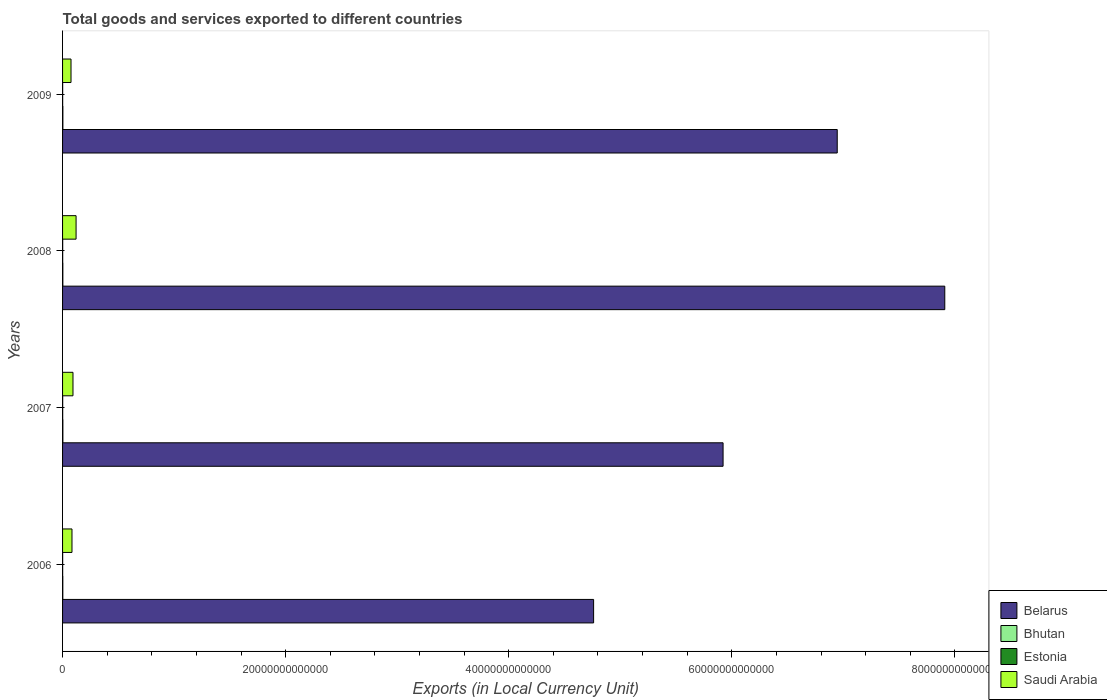How many different coloured bars are there?
Provide a short and direct response. 4. How many groups of bars are there?
Give a very brief answer. 4. How many bars are there on the 2nd tick from the top?
Provide a short and direct response. 4. How many bars are there on the 2nd tick from the bottom?
Give a very brief answer. 4. What is the label of the 3rd group of bars from the top?
Your answer should be very brief. 2007. In how many cases, is the number of bars for a given year not equal to the number of legend labels?
Your response must be concise. 0. What is the Amount of goods and services exports in Bhutan in 2007?
Offer a very short reply. 2.72e+1. Across all years, what is the maximum Amount of goods and services exports in Estonia?
Your answer should be very brief. 1.10e+1. Across all years, what is the minimum Amount of goods and services exports in Saudi Arabia?
Offer a terse response. 7.58e+11. In which year was the Amount of goods and services exports in Belarus minimum?
Offer a very short reply. 2006. What is the total Amount of goods and services exports in Bhutan in the graph?
Provide a short and direct response. 1.02e+11. What is the difference between the Amount of goods and services exports in Belarus in 2008 and that in 2009?
Provide a succinct answer. 9.64e+12. What is the difference between the Amount of goods and services exports in Belarus in 2006 and the Amount of goods and services exports in Estonia in 2009?
Ensure brevity in your answer.  4.76e+13. What is the average Amount of goods and services exports in Estonia per year?
Keep it short and to the point. 9.62e+09. In the year 2007, what is the difference between the Amount of goods and services exports in Belarus and Amount of goods and services exports in Estonia?
Your answer should be compact. 5.92e+13. In how many years, is the Amount of goods and services exports in Saudi Arabia greater than 48000000000000 LCU?
Your answer should be compact. 0. What is the ratio of the Amount of goods and services exports in Bhutan in 2008 to that in 2009?
Provide a short and direct response. 0.93. Is the difference between the Amount of goods and services exports in Belarus in 2008 and 2009 greater than the difference between the Amount of goods and services exports in Estonia in 2008 and 2009?
Keep it short and to the point. Yes. What is the difference between the highest and the second highest Amount of goods and services exports in Saudi Arabia?
Your answer should be very brief. 2.76e+11. What is the difference between the highest and the lowest Amount of goods and services exports in Estonia?
Offer a very short reply. 2.45e+09. What does the 1st bar from the top in 2009 represents?
Provide a succinct answer. Saudi Arabia. What does the 4th bar from the bottom in 2007 represents?
Your response must be concise. Saudi Arabia. Are all the bars in the graph horizontal?
Your answer should be compact. Yes. How many years are there in the graph?
Provide a succinct answer. 4. What is the difference between two consecutive major ticks on the X-axis?
Make the answer very short. 2.00e+13. Does the graph contain any zero values?
Provide a succinct answer. No. Does the graph contain grids?
Offer a terse response. No. How many legend labels are there?
Offer a terse response. 4. How are the legend labels stacked?
Provide a succinct answer. Vertical. What is the title of the graph?
Offer a terse response. Total goods and services exported to different countries. Does "El Salvador" appear as one of the legend labels in the graph?
Your answer should be compact. No. What is the label or title of the X-axis?
Provide a succinct answer. Exports (in Local Currency Unit). What is the Exports (in Local Currency Unit) of Belarus in 2006?
Ensure brevity in your answer.  4.76e+13. What is the Exports (in Local Currency Unit) of Bhutan in 2006?
Make the answer very short. 2.21e+1. What is the Exports (in Local Currency Unit) in Estonia in 2006?
Your answer should be compact. 8.58e+09. What is the Exports (in Local Currency Unit) in Saudi Arabia in 2006?
Ensure brevity in your answer.  8.45e+11. What is the Exports (in Local Currency Unit) in Belarus in 2007?
Make the answer very short. 5.92e+13. What is the Exports (in Local Currency Unit) in Bhutan in 2007?
Provide a short and direct response. 2.72e+1. What is the Exports (in Local Currency Unit) in Estonia in 2007?
Make the answer very short. 1.03e+1. What is the Exports (in Local Currency Unit) of Saudi Arabia in 2007?
Your answer should be compact. 9.34e+11. What is the Exports (in Local Currency Unit) of Belarus in 2008?
Offer a terse response. 7.91e+13. What is the Exports (in Local Currency Unit) of Bhutan in 2008?
Provide a short and direct response. 2.55e+1. What is the Exports (in Local Currency Unit) in Estonia in 2008?
Give a very brief answer. 1.10e+1. What is the Exports (in Local Currency Unit) of Saudi Arabia in 2008?
Your answer should be compact. 1.21e+12. What is the Exports (in Local Currency Unit) in Belarus in 2009?
Give a very brief answer. 6.94e+13. What is the Exports (in Local Currency Unit) in Bhutan in 2009?
Ensure brevity in your answer.  2.74e+1. What is the Exports (in Local Currency Unit) in Estonia in 2009?
Offer a very short reply. 8.60e+09. What is the Exports (in Local Currency Unit) in Saudi Arabia in 2009?
Your answer should be very brief. 7.58e+11. Across all years, what is the maximum Exports (in Local Currency Unit) of Belarus?
Offer a terse response. 7.91e+13. Across all years, what is the maximum Exports (in Local Currency Unit) of Bhutan?
Offer a terse response. 2.74e+1. Across all years, what is the maximum Exports (in Local Currency Unit) in Estonia?
Give a very brief answer. 1.10e+1. Across all years, what is the maximum Exports (in Local Currency Unit) of Saudi Arabia?
Ensure brevity in your answer.  1.21e+12. Across all years, what is the minimum Exports (in Local Currency Unit) in Belarus?
Give a very brief answer. 4.76e+13. Across all years, what is the minimum Exports (in Local Currency Unit) of Bhutan?
Give a very brief answer. 2.21e+1. Across all years, what is the minimum Exports (in Local Currency Unit) of Estonia?
Give a very brief answer. 8.58e+09. Across all years, what is the minimum Exports (in Local Currency Unit) in Saudi Arabia?
Provide a succinct answer. 7.58e+11. What is the total Exports (in Local Currency Unit) of Belarus in the graph?
Provide a succinct answer. 2.55e+14. What is the total Exports (in Local Currency Unit) in Bhutan in the graph?
Your response must be concise. 1.02e+11. What is the total Exports (in Local Currency Unit) of Estonia in the graph?
Provide a succinct answer. 3.85e+1. What is the total Exports (in Local Currency Unit) in Saudi Arabia in the graph?
Provide a short and direct response. 3.75e+12. What is the difference between the Exports (in Local Currency Unit) in Belarus in 2006 and that in 2007?
Make the answer very short. -1.16e+13. What is the difference between the Exports (in Local Currency Unit) of Bhutan in 2006 and that in 2007?
Provide a succinct answer. -5.05e+09. What is the difference between the Exports (in Local Currency Unit) in Estonia in 2006 and that in 2007?
Give a very brief answer. -1.68e+09. What is the difference between the Exports (in Local Currency Unit) in Saudi Arabia in 2006 and that in 2007?
Offer a very short reply. -8.98e+1. What is the difference between the Exports (in Local Currency Unit) of Belarus in 2006 and that in 2008?
Your answer should be very brief. -3.15e+13. What is the difference between the Exports (in Local Currency Unit) of Bhutan in 2006 and that in 2008?
Ensure brevity in your answer.  -3.35e+09. What is the difference between the Exports (in Local Currency Unit) of Estonia in 2006 and that in 2008?
Ensure brevity in your answer.  -2.45e+09. What is the difference between the Exports (in Local Currency Unit) in Saudi Arabia in 2006 and that in 2008?
Your answer should be very brief. -3.66e+11. What is the difference between the Exports (in Local Currency Unit) of Belarus in 2006 and that in 2009?
Your response must be concise. -2.18e+13. What is the difference between the Exports (in Local Currency Unit) in Bhutan in 2006 and that in 2009?
Ensure brevity in your answer.  -5.23e+09. What is the difference between the Exports (in Local Currency Unit) in Estonia in 2006 and that in 2009?
Your response must be concise. -1.66e+07. What is the difference between the Exports (in Local Currency Unit) of Saudi Arabia in 2006 and that in 2009?
Ensure brevity in your answer.  8.68e+1. What is the difference between the Exports (in Local Currency Unit) of Belarus in 2007 and that in 2008?
Offer a very short reply. -1.99e+13. What is the difference between the Exports (in Local Currency Unit) of Bhutan in 2007 and that in 2008?
Your response must be concise. 1.70e+09. What is the difference between the Exports (in Local Currency Unit) of Estonia in 2007 and that in 2008?
Keep it short and to the point. -7.66e+08. What is the difference between the Exports (in Local Currency Unit) in Saudi Arabia in 2007 and that in 2008?
Your answer should be very brief. -2.76e+11. What is the difference between the Exports (in Local Currency Unit) of Belarus in 2007 and that in 2009?
Keep it short and to the point. -1.02e+13. What is the difference between the Exports (in Local Currency Unit) of Bhutan in 2007 and that in 2009?
Provide a short and direct response. -1.80e+08. What is the difference between the Exports (in Local Currency Unit) of Estonia in 2007 and that in 2009?
Your answer should be very brief. 1.67e+09. What is the difference between the Exports (in Local Currency Unit) of Saudi Arabia in 2007 and that in 2009?
Provide a succinct answer. 1.77e+11. What is the difference between the Exports (in Local Currency Unit) in Belarus in 2008 and that in 2009?
Make the answer very short. 9.64e+12. What is the difference between the Exports (in Local Currency Unit) of Bhutan in 2008 and that in 2009?
Provide a short and direct response. -1.88e+09. What is the difference between the Exports (in Local Currency Unit) of Estonia in 2008 and that in 2009?
Your answer should be compact. 2.43e+09. What is the difference between the Exports (in Local Currency Unit) in Saudi Arabia in 2008 and that in 2009?
Offer a very short reply. 4.53e+11. What is the difference between the Exports (in Local Currency Unit) of Belarus in 2006 and the Exports (in Local Currency Unit) of Bhutan in 2007?
Provide a short and direct response. 4.76e+13. What is the difference between the Exports (in Local Currency Unit) in Belarus in 2006 and the Exports (in Local Currency Unit) in Estonia in 2007?
Offer a very short reply. 4.76e+13. What is the difference between the Exports (in Local Currency Unit) in Belarus in 2006 and the Exports (in Local Currency Unit) in Saudi Arabia in 2007?
Your response must be concise. 4.67e+13. What is the difference between the Exports (in Local Currency Unit) of Bhutan in 2006 and the Exports (in Local Currency Unit) of Estonia in 2007?
Offer a terse response. 1.19e+1. What is the difference between the Exports (in Local Currency Unit) in Bhutan in 2006 and the Exports (in Local Currency Unit) in Saudi Arabia in 2007?
Your answer should be compact. -9.12e+11. What is the difference between the Exports (in Local Currency Unit) of Estonia in 2006 and the Exports (in Local Currency Unit) of Saudi Arabia in 2007?
Make the answer very short. -9.26e+11. What is the difference between the Exports (in Local Currency Unit) in Belarus in 2006 and the Exports (in Local Currency Unit) in Bhutan in 2008?
Your answer should be compact. 4.76e+13. What is the difference between the Exports (in Local Currency Unit) of Belarus in 2006 and the Exports (in Local Currency Unit) of Estonia in 2008?
Your response must be concise. 4.76e+13. What is the difference between the Exports (in Local Currency Unit) of Belarus in 2006 and the Exports (in Local Currency Unit) of Saudi Arabia in 2008?
Your answer should be very brief. 4.64e+13. What is the difference between the Exports (in Local Currency Unit) in Bhutan in 2006 and the Exports (in Local Currency Unit) in Estonia in 2008?
Give a very brief answer. 1.11e+1. What is the difference between the Exports (in Local Currency Unit) of Bhutan in 2006 and the Exports (in Local Currency Unit) of Saudi Arabia in 2008?
Provide a short and direct response. -1.19e+12. What is the difference between the Exports (in Local Currency Unit) of Estonia in 2006 and the Exports (in Local Currency Unit) of Saudi Arabia in 2008?
Offer a terse response. -1.20e+12. What is the difference between the Exports (in Local Currency Unit) of Belarus in 2006 and the Exports (in Local Currency Unit) of Bhutan in 2009?
Provide a short and direct response. 4.76e+13. What is the difference between the Exports (in Local Currency Unit) of Belarus in 2006 and the Exports (in Local Currency Unit) of Estonia in 2009?
Your answer should be very brief. 4.76e+13. What is the difference between the Exports (in Local Currency Unit) of Belarus in 2006 and the Exports (in Local Currency Unit) of Saudi Arabia in 2009?
Your answer should be compact. 4.69e+13. What is the difference between the Exports (in Local Currency Unit) in Bhutan in 2006 and the Exports (in Local Currency Unit) in Estonia in 2009?
Offer a terse response. 1.35e+1. What is the difference between the Exports (in Local Currency Unit) in Bhutan in 2006 and the Exports (in Local Currency Unit) in Saudi Arabia in 2009?
Make the answer very short. -7.36e+11. What is the difference between the Exports (in Local Currency Unit) in Estonia in 2006 and the Exports (in Local Currency Unit) in Saudi Arabia in 2009?
Keep it short and to the point. -7.49e+11. What is the difference between the Exports (in Local Currency Unit) in Belarus in 2007 and the Exports (in Local Currency Unit) in Bhutan in 2008?
Make the answer very short. 5.92e+13. What is the difference between the Exports (in Local Currency Unit) of Belarus in 2007 and the Exports (in Local Currency Unit) of Estonia in 2008?
Make the answer very short. 5.92e+13. What is the difference between the Exports (in Local Currency Unit) in Belarus in 2007 and the Exports (in Local Currency Unit) in Saudi Arabia in 2008?
Your response must be concise. 5.80e+13. What is the difference between the Exports (in Local Currency Unit) in Bhutan in 2007 and the Exports (in Local Currency Unit) in Estonia in 2008?
Ensure brevity in your answer.  1.62e+1. What is the difference between the Exports (in Local Currency Unit) of Bhutan in 2007 and the Exports (in Local Currency Unit) of Saudi Arabia in 2008?
Your answer should be compact. -1.18e+12. What is the difference between the Exports (in Local Currency Unit) of Estonia in 2007 and the Exports (in Local Currency Unit) of Saudi Arabia in 2008?
Give a very brief answer. -1.20e+12. What is the difference between the Exports (in Local Currency Unit) of Belarus in 2007 and the Exports (in Local Currency Unit) of Bhutan in 2009?
Your answer should be very brief. 5.92e+13. What is the difference between the Exports (in Local Currency Unit) in Belarus in 2007 and the Exports (in Local Currency Unit) in Estonia in 2009?
Your answer should be compact. 5.92e+13. What is the difference between the Exports (in Local Currency Unit) of Belarus in 2007 and the Exports (in Local Currency Unit) of Saudi Arabia in 2009?
Make the answer very short. 5.85e+13. What is the difference between the Exports (in Local Currency Unit) in Bhutan in 2007 and the Exports (in Local Currency Unit) in Estonia in 2009?
Give a very brief answer. 1.86e+1. What is the difference between the Exports (in Local Currency Unit) of Bhutan in 2007 and the Exports (in Local Currency Unit) of Saudi Arabia in 2009?
Keep it short and to the point. -7.31e+11. What is the difference between the Exports (in Local Currency Unit) of Estonia in 2007 and the Exports (in Local Currency Unit) of Saudi Arabia in 2009?
Your answer should be compact. -7.47e+11. What is the difference between the Exports (in Local Currency Unit) in Belarus in 2008 and the Exports (in Local Currency Unit) in Bhutan in 2009?
Make the answer very short. 7.91e+13. What is the difference between the Exports (in Local Currency Unit) of Belarus in 2008 and the Exports (in Local Currency Unit) of Estonia in 2009?
Provide a succinct answer. 7.91e+13. What is the difference between the Exports (in Local Currency Unit) of Belarus in 2008 and the Exports (in Local Currency Unit) of Saudi Arabia in 2009?
Your answer should be very brief. 7.83e+13. What is the difference between the Exports (in Local Currency Unit) of Bhutan in 2008 and the Exports (in Local Currency Unit) of Estonia in 2009?
Keep it short and to the point. 1.69e+1. What is the difference between the Exports (in Local Currency Unit) in Bhutan in 2008 and the Exports (in Local Currency Unit) in Saudi Arabia in 2009?
Make the answer very short. -7.32e+11. What is the difference between the Exports (in Local Currency Unit) in Estonia in 2008 and the Exports (in Local Currency Unit) in Saudi Arabia in 2009?
Provide a short and direct response. -7.47e+11. What is the average Exports (in Local Currency Unit) of Belarus per year?
Provide a succinct answer. 6.38e+13. What is the average Exports (in Local Currency Unit) of Bhutan per year?
Your response must be concise. 2.55e+1. What is the average Exports (in Local Currency Unit) in Estonia per year?
Offer a very short reply. 9.62e+09. What is the average Exports (in Local Currency Unit) of Saudi Arabia per year?
Make the answer very short. 9.37e+11. In the year 2006, what is the difference between the Exports (in Local Currency Unit) in Belarus and Exports (in Local Currency Unit) in Bhutan?
Your response must be concise. 4.76e+13. In the year 2006, what is the difference between the Exports (in Local Currency Unit) in Belarus and Exports (in Local Currency Unit) in Estonia?
Provide a short and direct response. 4.76e+13. In the year 2006, what is the difference between the Exports (in Local Currency Unit) in Belarus and Exports (in Local Currency Unit) in Saudi Arabia?
Your answer should be very brief. 4.68e+13. In the year 2006, what is the difference between the Exports (in Local Currency Unit) in Bhutan and Exports (in Local Currency Unit) in Estonia?
Provide a succinct answer. 1.35e+1. In the year 2006, what is the difference between the Exports (in Local Currency Unit) in Bhutan and Exports (in Local Currency Unit) in Saudi Arabia?
Provide a short and direct response. -8.22e+11. In the year 2006, what is the difference between the Exports (in Local Currency Unit) in Estonia and Exports (in Local Currency Unit) in Saudi Arabia?
Provide a succinct answer. -8.36e+11. In the year 2007, what is the difference between the Exports (in Local Currency Unit) of Belarus and Exports (in Local Currency Unit) of Bhutan?
Keep it short and to the point. 5.92e+13. In the year 2007, what is the difference between the Exports (in Local Currency Unit) in Belarus and Exports (in Local Currency Unit) in Estonia?
Make the answer very short. 5.92e+13. In the year 2007, what is the difference between the Exports (in Local Currency Unit) of Belarus and Exports (in Local Currency Unit) of Saudi Arabia?
Provide a short and direct response. 5.83e+13. In the year 2007, what is the difference between the Exports (in Local Currency Unit) of Bhutan and Exports (in Local Currency Unit) of Estonia?
Keep it short and to the point. 1.69e+1. In the year 2007, what is the difference between the Exports (in Local Currency Unit) of Bhutan and Exports (in Local Currency Unit) of Saudi Arabia?
Offer a terse response. -9.07e+11. In the year 2007, what is the difference between the Exports (in Local Currency Unit) of Estonia and Exports (in Local Currency Unit) of Saudi Arabia?
Provide a short and direct response. -9.24e+11. In the year 2008, what is the difference between the Exports (in Local Currency Unit) in Belarus and Exports (in Local Currency Unit) in Bhutan?
Your response must be concise. 7.91e+13. In the year 2008, what is the difference between the Exports (in Local Currency Unit) in Belarus and Exports (in Local Currency Unit) in Estonia?
Give a very brief answer. 7.91e+13. In the year 2008, what is the difference between the Exports (in Local Currency Unit) of Belarus and Exports (in Local Currency Unit) of Saudi Arabia?
Provide a short and direct response. 7.79e+13. In the year 2008, what is the difference between the Exports (in Local Currency Unit) in Bhutan and Exports (in Local Currency Unit) in Estonia?
Give a very brief answer. 1.45e+1. In the year 2008, what is the difference between the Exports (in Local Currency Unit) in Bhutan and Exports (in Local Currency Unit) in Saudi Arabia?
Your response must be concise. -1.19e+12. In the year 2008, what is the difference between the Exports (in Local Currency Unit) of Estonia and Exports (in Local Currency Unit) of Saudi Arabia?
Give a very brief answer. -1.20e+12. In the year 2009, what is the difference between the Exports (in Local Currency Unit) in Belarus and Exports (in Local Currency Unit) in Bhutan?
Keep it short and to the point. 6.94e+13. In the year 2009, what is the difference between the Exports (in Local Currency Unit) of Belarus and Exports (in Local Currency Unit) of Estonia?
Your response must be concise. 6.94e+13. In the year 2009, what is the difference between the Exports (in Local Currency Unit) of Belarus and Exports (in Local Currency Unit) of Saudi Arabia?
Offer a terse response. 6.87e+13. In the year 2009, what is the difference between the Exports (in Local Currency Unit) of Bhutan and Exports (in Local Currency Unit) of Estonia?
Offer a very short reply. 1.88e+1. In the year 2009, what is the difference between the Exports (in Local Currency Unit) in Bhutan and Exports (in Local Currency Unit) in Saudi Arabia?
Provide a succinct answer. -7.30e+11. In the year 2009, what is the difference between the Exports (in Local Currency Unit) of Estonia and Exports (in Local Currency Unit) of Saudi Arabia?
Your response must be concise. -7.49e+11. What is the ratio of the Exports (in Local Currency Unit) of Belarus in 2006 to that in 2007?
Provide a short and direct response. 0.8. What is the ratio of the Exports (in Local Currency Unit) of Bhutan in 2006 to that in 2007?
Your answer should be very brief. 0.81. What is the ratio of the Exports (in Local Currency Unit) of Estonia in 2006 to that in 2007?
Ensure brevity in your answer.  0.84. What is the ratio of the Exports (in Local Currency Unit) of Saudi Arabia in 2006 to that in 2007?
Provide a short and direct response. 0.9. What is the ratio of the Exports (in Local Currency Unit) of Belarus in 2006 to that in 2008?
Your response must be concise. 0.6. What is the ratio of the Exports (in Local Currency Unit) of Bhutan in 2006 to that in 2008?
Offer a terse response. 0.87. What is the ratio of the Exports (in Local Currency Unit) in Estonia in 2006 to that in 2008?
Provide a short and direct response. 0.78. What is the ratio of the Exports (in Local Currency Unit) in Saudi Arabia in 2006 to that in 2008?
Provide a short and direct response. 0.7. What is the ratio of the Exports (in Local Currency Unit) of Belarus in 2006 to that in 2009?
Ensure brevity in your answer.  0.69. What is the ratio of the Exports (in Local Currency Unit) of Bhutan in 2006 to that in 2009?
Offer a terse response. 0.81. What is the ratio of the Exports (in Local Currency Unit) of Saudi Arabia in 2006 to that in 2009?
Your answer should be very brief. 1.11. What is the ratio of the Exports (in Local Currency Unit) in Belarus in 2007 to that in 2008?
Offer a terse response. 0.75. What is the ratio of the Exports (in Local Currency Unit) in Bhutan in 2007 to that in 2008?
Provide a succinct answer. 1.07. What is the ratio of the Exports (in Local Currency Unit) in Estonia in 2007 to that in 2008?
Your response must be concise. 0.93. What is the ratio of the Exports (in Local Currency Unit) of Saudi Arabia in 2007 to that in 2008?
Provide a succinct answer. 0.77. What is the ratio of the Exports (in Local Currency Unit) in Belarus in 2007 to that in 2009?
Your answer should be compact. 0.85. What is the ratio of the Exports (in Local Currency Unit) of Bhutan in 2007 to that in 2009?
Offer a very short reply. 0.99. What is the ratio of the Exports (in Local Currency Unit) of Estonia in 2007 to that in 2009?
Your response must be concise. 1.19. What is the ratio of the Exports (in Local Currency Unit) of Saudi Arabia in 2007 to that in 2009?
Your answer should be very brief. 1.23. What is the ratio of the Exports (in Local Currency Unit) in Belarus in 2008 to that in 2009?
Make the answer very short. 1.14. What is the ratio of the Exports (in Local Currency Unit) in Bhutan in 2008 to that in 2009?
Your answer should be compact. 0.93. What is the ratio of the Exports (in Local Currency Unit) of Estonia in 2008 to that in 2009?
Provide a succinct answer. 1.28. What is the ratio of the Exports (in Local Currency Unit) of Saudi Arabia in 2008 to that in 2009?
Your answer should be very brief. 1.6. What is the difference between the highest and the second highest Exports (in Local Currency Unit) of Belarus?
Offer a very short reply. 9.64e+12. What is the difference between the highest and the second highest Exports (in Local Currency Unit) in Bhutan?
Give a very brief answer. 1.80e+08. What is the difference between the highest and the second highest Exports (in Local Currency Unit) in Estonia?
Ensure brevity in your answer.  7.66e+08. What is the difference between the highest and the second highest Exports (in Local Currency Unit) in Saudi Arabia?
Your answer should be very brief. 2.76e+11. What is the difference between the highest and the lowest Exports (in Local Currency Unit) in Belarus?
Your answer should be compact. 3.15e+13. What is the difference between the highest and the lowest Exports (in Local Currency Unit) in Bhutan?
Give a very brief answer. 5.23e+09. What is the difference between the highest and the lowest Exports (in Local Currency Unit) in Estonia?
Your answer should be compact. 2.45e+09. What is the difference between the highest and the lowest Exports (in Local Currency Unit) in Saudi Arabia?
Give a very brief answer. 4.53e+11. 